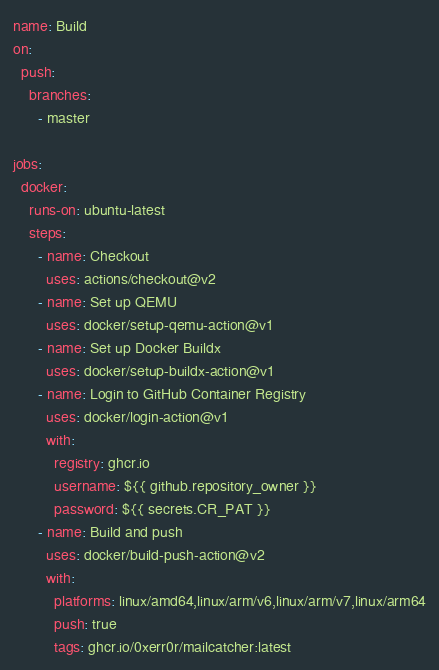<code> <loc_0><loc_0><loc_500><loc_500><_YAML_>name: Build
on:
  push:
    branches:
      - master

jobs:
  docker:
    runs-on: ubuntu-latest
    steps:
      - name: Checkout
        uses: actions/checkout@v2
      - name: Set up QEMU
        uses: docker/setup-qemu-action@v1
      - name: Set up Docker Buildx
        uses: docker/setup-buildx-action@v1
      - name: Login to GitHub Container Registry
        uses: docker/login-action@v1
        with:
          registry: ghcr.io
          username: ${{ github.repository_owner }}
          password: ${{ secrets.CR_PAT }}
      - name: Build and push
        uses: docker/build-push-action@v2
        with:
          platforms: linux/amd64,linux/arm/v6,linux/arm/v7,linux/arm64
          push: true
          tags: ghcr.io/0xerr0r/mailcatcher:latest
</code> 